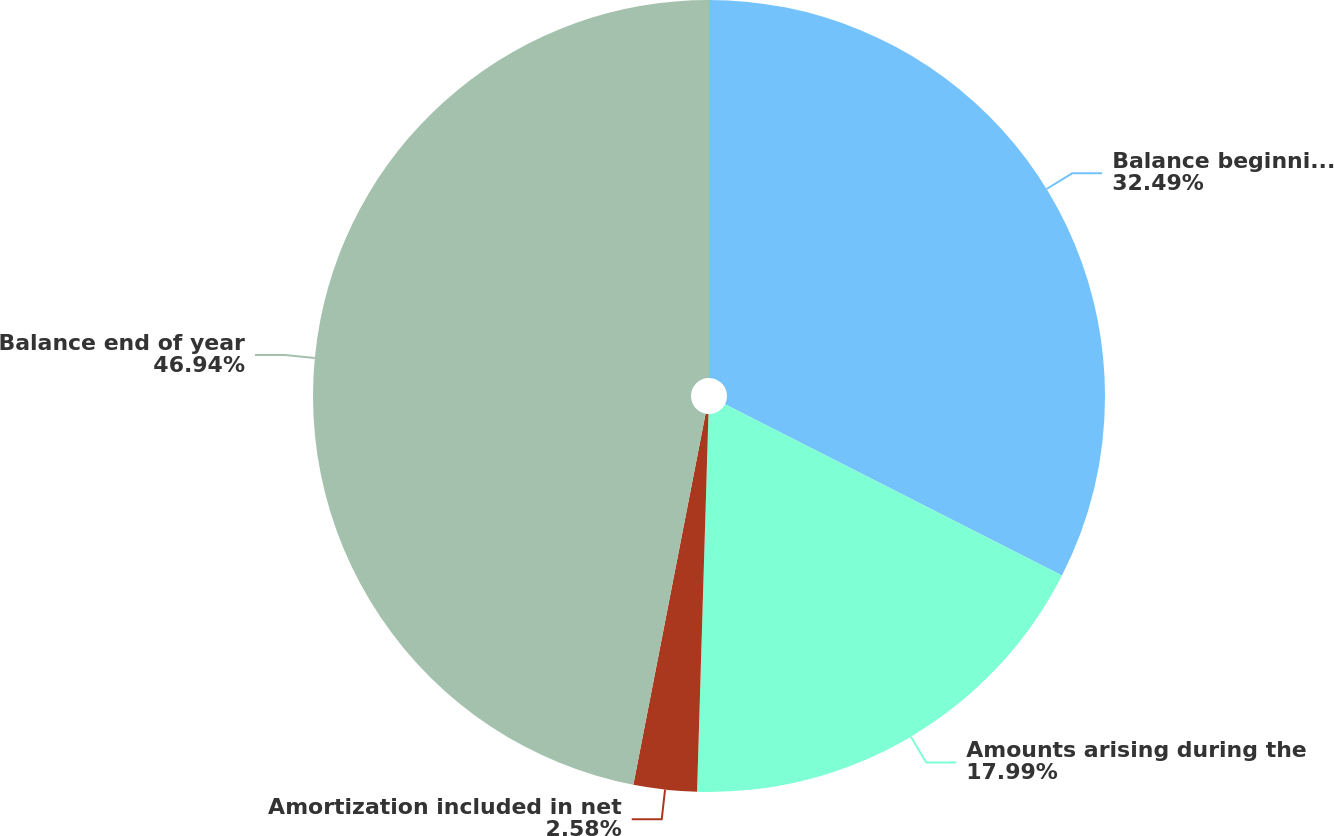<chart> <loc_0><loc_0><loc_500><loc_500><pie_chart><fcel>Balance beginning of year<fcel>Amounts arising during the<fcel>Amortization included in net<fcel>Balance end of year<nl><fcel>32.49%<fcel>17.99%<fcel>2.58%<fcel>46.94%<nl></chart> 